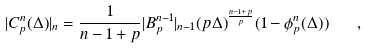Convert formula to latex. <formula><loc_0><loc_0><loc_500><loc_500>| C _ { p } ^ { n } ( \Delta ) | _ { n } = \frac { 1 } { n - 1 + p } | B _ { p } ^ { n - 1 } | _ { n - 1 } ( p \Delta ) ^ { \frac { n - 1 + p } { p } } ( 1 - \phi _ { p } ^ { n } ( \Delta ) ) \quad ,</formula> 